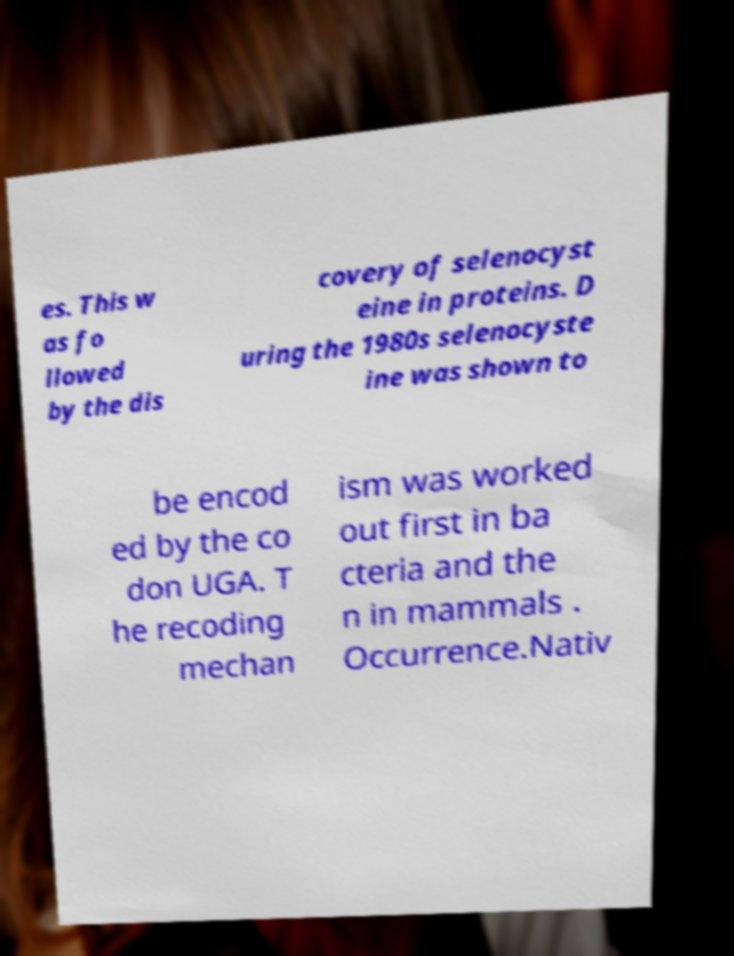Could you extract and type out the text from this image? es. This w as fo llowed by the dis covery of selenocyst eine in proteins. D uring the 1980s selenocyste ine was shown to be encod ed by the co don UGA. T he recoding mechan ism was worked out first in ba cteria and the n in mammals . Occurrence.Nativ 